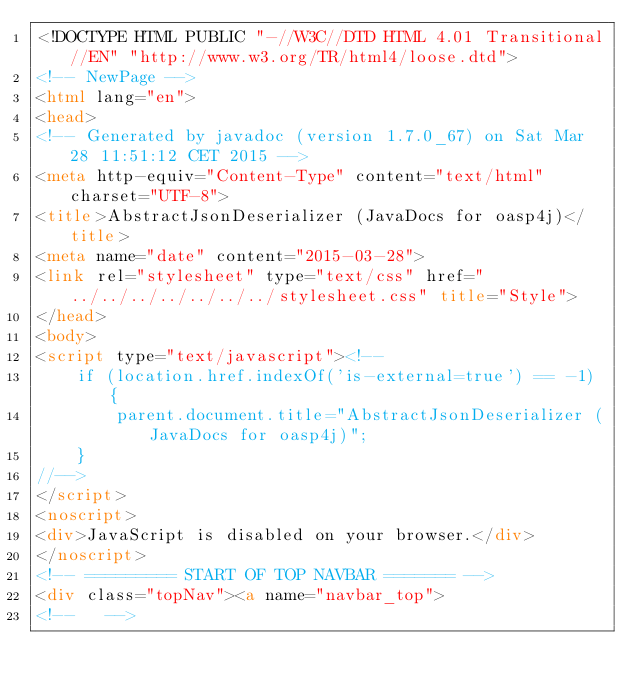Convert code to text. <code><loc_0><loc_0><loc_500><loc_500><_HTML_><!DOCTYPE HTML PUBLIC "-//W3C//DTD HTML 4.01 Transitional//EN" "http://www.w3.org/TR/html4/loose.dtd">
<!-- NewPage -->
<html lang="en">
<head>
<!-- Generated by javadoc (version 1.7.0_67) on Sat Mar 28 11:51:12 CET 2015 -->
<meta http-equiv="Content-Type" content="text/html" charset="UTF-8">
<title>AbstractJsonDeserializer (JavaDocs for oasp4j)</title>
<meta name="date" content="2015-03-28">
<link rel="stylesheet" type="text/css" href="../../../../../../../stylesheet.css" title="Style">
</head>
<body>
<script type="text/javascript"><!--
    if (location.href.indexOf('is-external=true') == -1) {
        parent.document.title="AbstractJsonDeserializer (JavaDocs for oasp4j)";
    }
//-->
</script>
<noscript>
<div>JavaScript is disabled on your browser.</div>
</noscript>
<!-- ========= START OF TOP NAVBAR ======= -->
<div class="topNav"><a name="navbar_top">
<!--   --></code> 